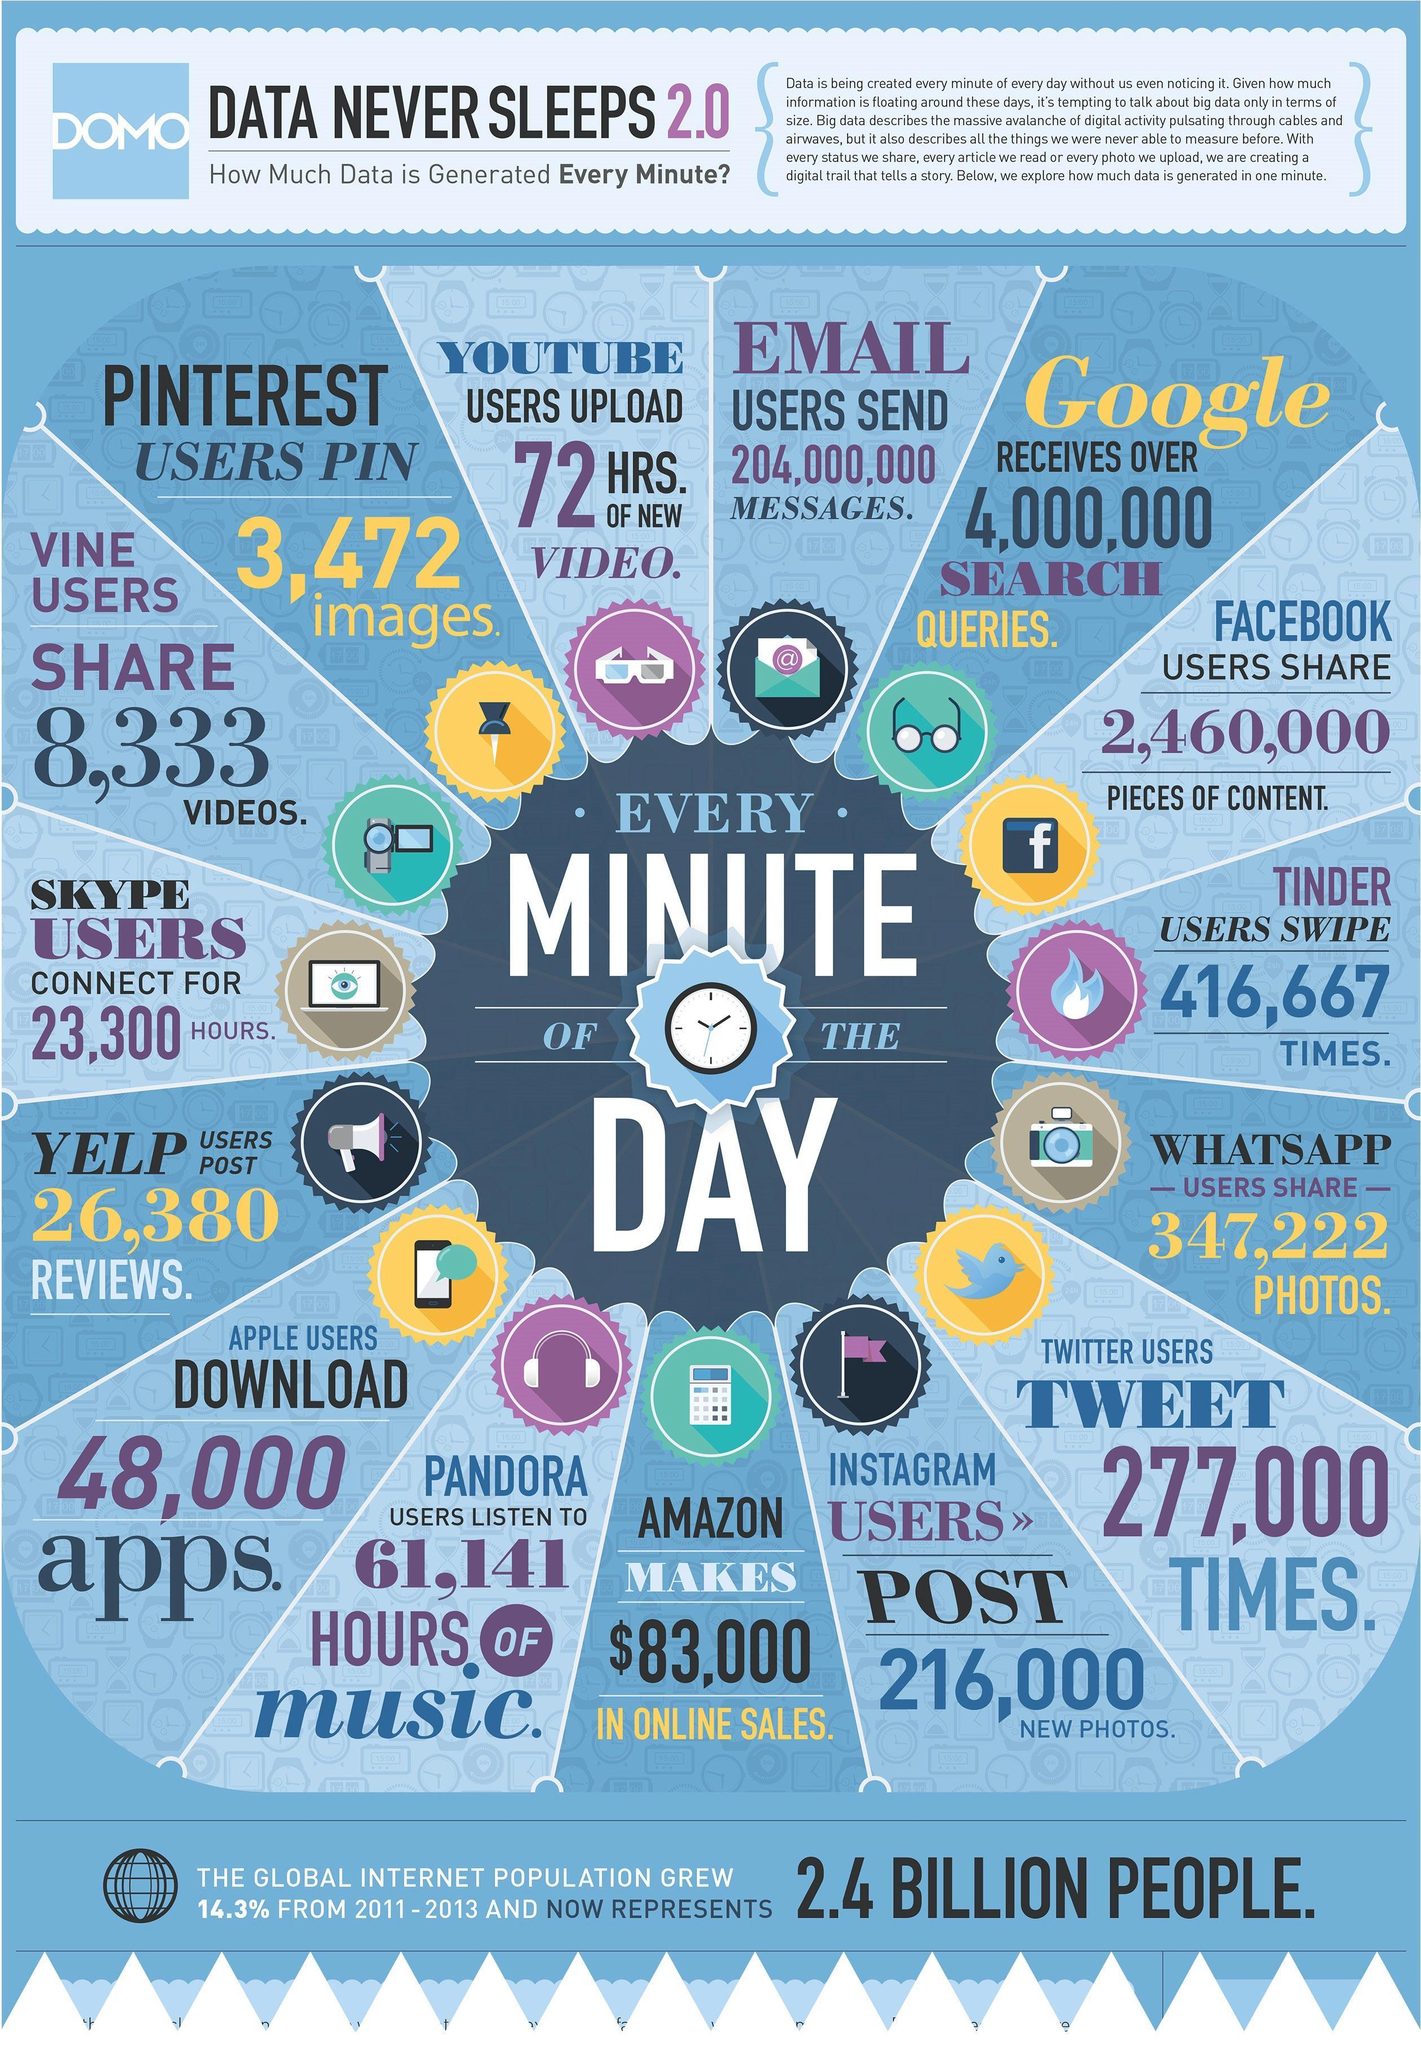What is the no of images Pinterest users pin every minute of the day?
Answer the question with a short phrase. 3,472 images. What is the length of new videos uploaded by youtube users every minute of the day? 72 HRS. How many new photos were posted by instagram users every minute of the day? 216,000 How many search queries google receives every minute of the day? over 4,000,000 How many times twitter users tweet every minute of the day? 277,000 What is the amount of money amazon makes in online sales every minute of the day? $83,000 What is the number of apps downloaded by apple users every minute of the day? 48,000 How many reviews were posted by yelp users every minute of the day? 26,380 How many hours Skype users stay connected every minute of the day? 23,300 